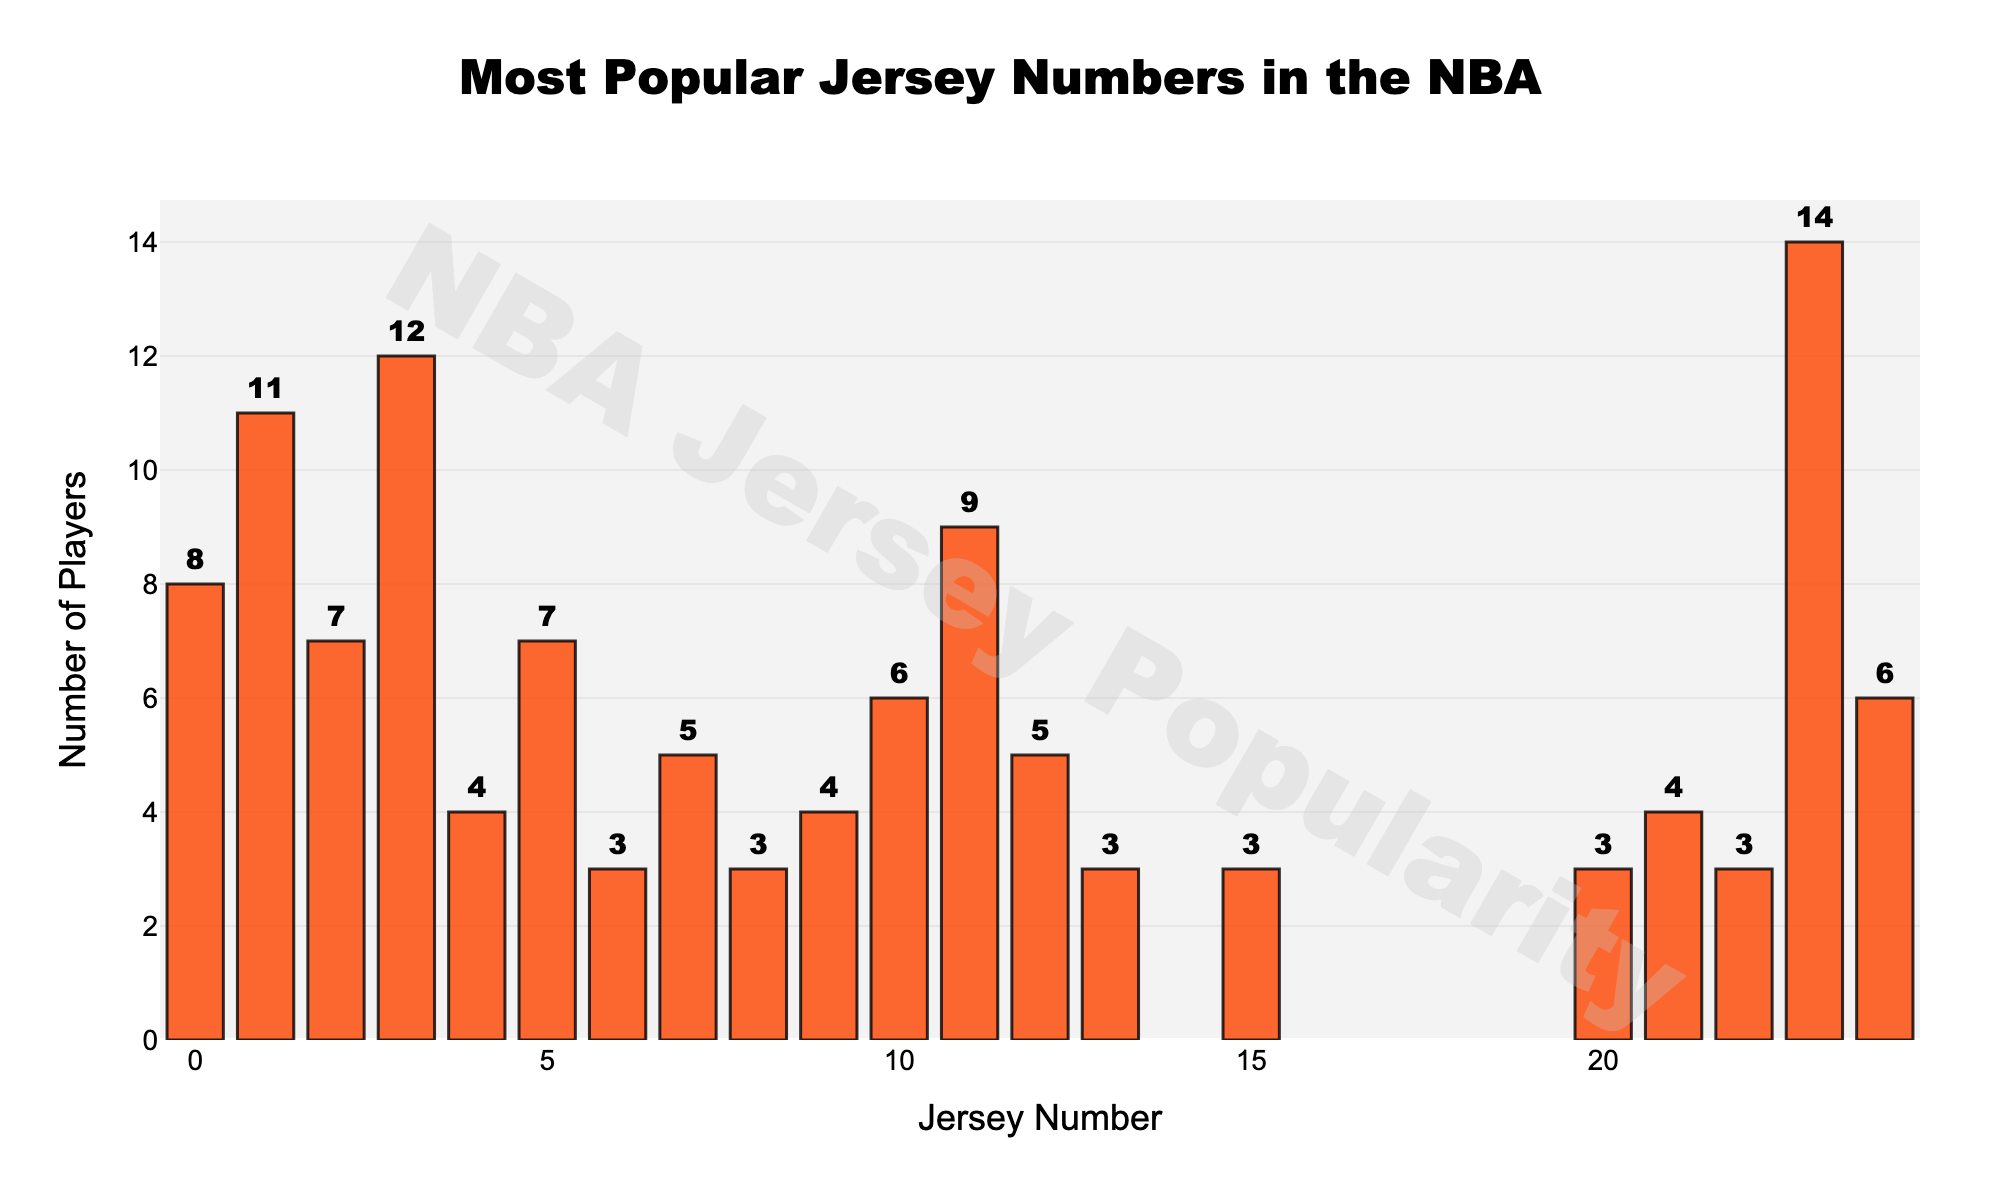What is the most popular jersey number among NBA players? The most popular jersey number is the one with the highest bar in the chart, which corresponds to the jersey number 23 with a popularity of 14 players.
Answer: 23 Which jersey numbers have the same popularity? To find this, look for bars of the same height. The jersey numbers 5 and 2, both with a popularity of 7, and 24 and 10, each with a popularity of 6, are examples of the same popularity.
Answer: 5 and 2; 24 and 10 What is the total number of players that have jersey numbers 3, 1, and 11? Add the popularity values of these three jersey numbers: 12 (for 3) + 11 (for 1) + 9 (for 11) = 32 players.
Answer: 32 Which jersey number is more common, 0 or 5? Compare the heights of the bars for jersey numbers 0 and 5. The jersey number 0 has a popularity of 8, while 5 has a popularity of 7. Therefore, 0 is more common.
Answer: 0 How many jersey numbers are more popular than jersey number 7? Count the bars that are taller than the bar for jersey number 7. These are 23, 3, 1, 11, 0, 5, 2, 10, 24, and 12. Thus, there are 10 jersey numbers more popular than 7.
Answer: 10 Are there more players wearing jersey number 8 or jersey number 6? Compare the heights of the bars for jersey numbers 8 and 6. The jersey number 8 has a popularity of 3, the same number as jersey number 6.
Answer: They are equal What is the cumulative popularity of the jersey numbers 9, 4, and 21? Add the popularity values of these three jersey numbers: 4 (for 9) + 4 (for 4) + 4 (for 21) = 12 players.
Answer: 12 How does the popularity of jersey number 15 compare to that of jersey number 8? Compare the heights of the bars for jersey numbers 15 and 8. The popularity for both jersey numbers 15 and 8 is 3, indicating they have the same popularity.
Answer: They are equal What is the average popularity of the top 5 most popular jersey numbers? Find the top 5 most popular jersey numbers (23, 3, 1, 11, 0) and compute their average. The popularity values are 14, 12, 11, 9, and 8. The sum is 14 + 12 + 11 + 9 + 8 = 54, and the average is 54 / 5 = 10.8
Answer: 10.8 